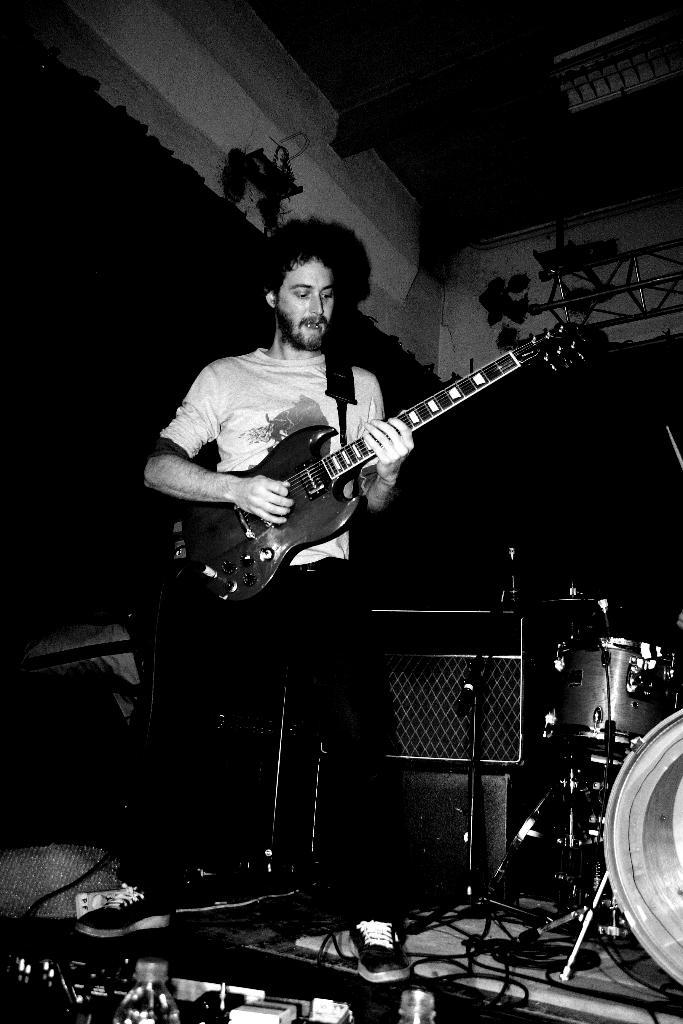Who is in the image? There is a man in the image. Where is the man located in the image? The man is standing on the left side of the image. What is the man doing in the image? The man is playing the guitar. What other musical instrument can be seen in the image? There is a drum set on the right side of the image. What type of chess pieces can be seen on the drum set in the image? There are no chess pieces present on the drum set in the image. How does the man protect himself from the rainstorm in the image? There is no rainstorm present in the image, so the man does not need to protect himself from it. 